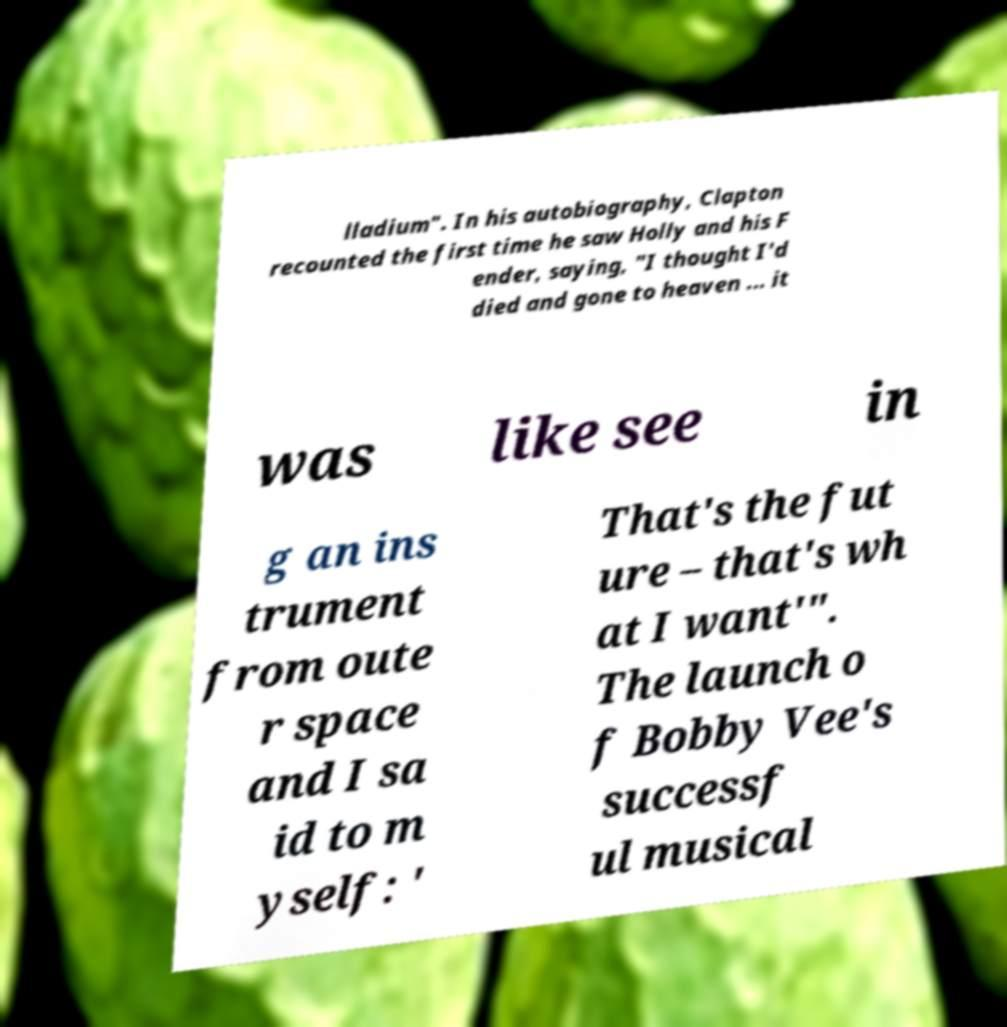Please identify and transcribe the text found in this image. lladium". In his autobiography, Clapton recounted the first time he saw Holly and his F ender, saying, "I thought I'd died and gone to heaven ... it was like see in g an ins trument from oute r space and I sa id to m yself: ' That's the fut ure – that's wh at I want'". The launch o f Bobby Vee's successf ul musical 